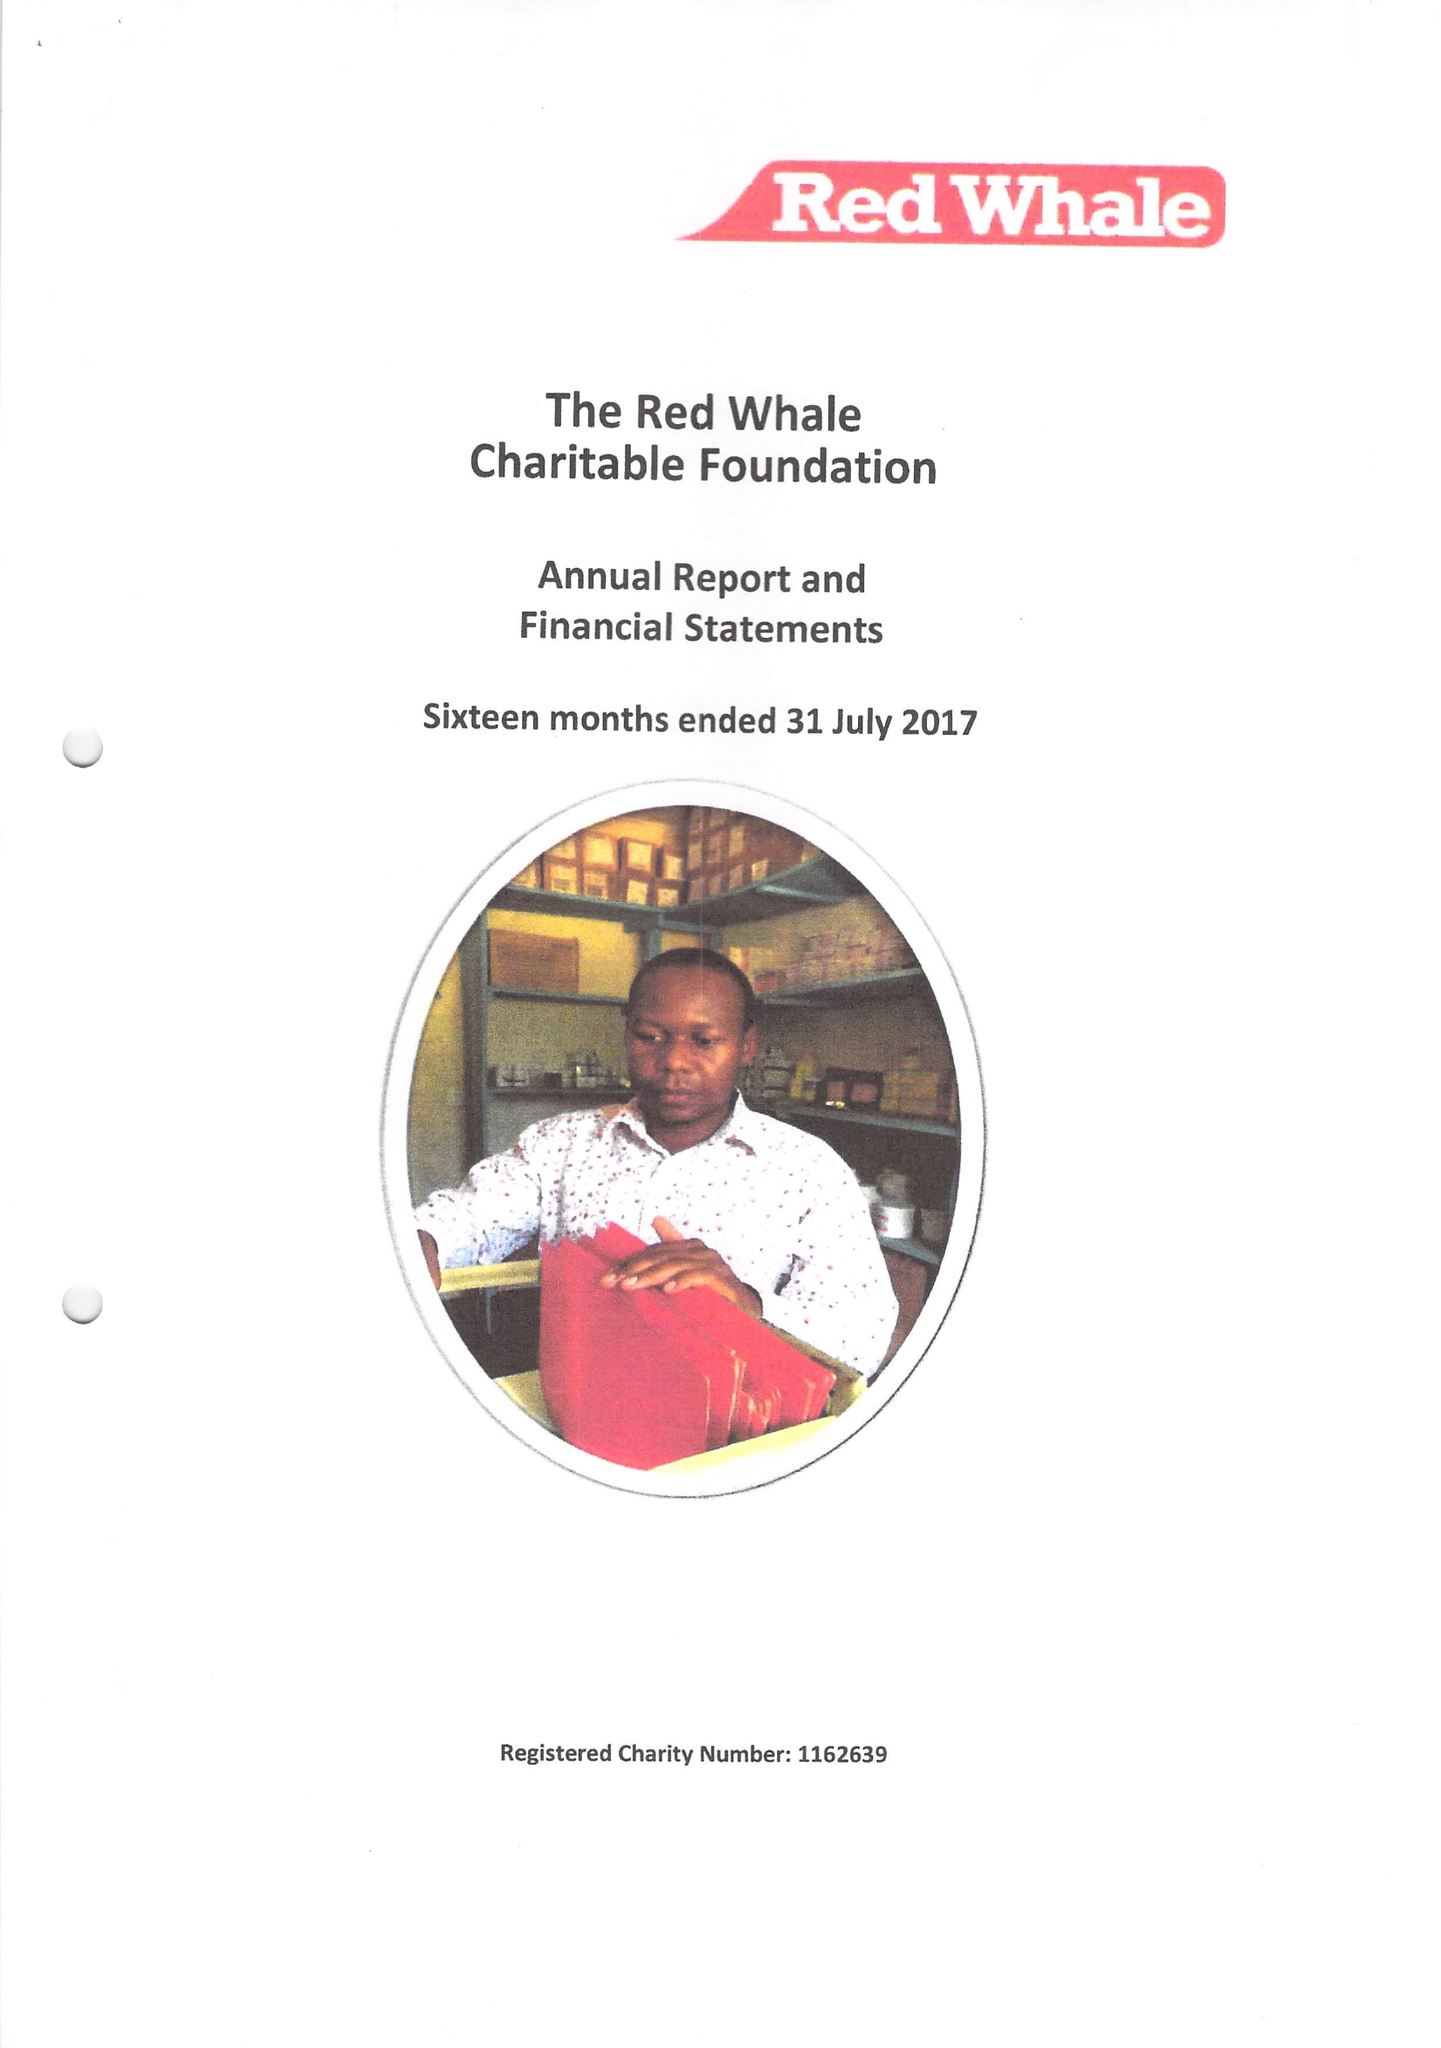What is the value for the address__street_line?
Answer the question using a single word or phrase. WHITEKNIGHTS ROAD 